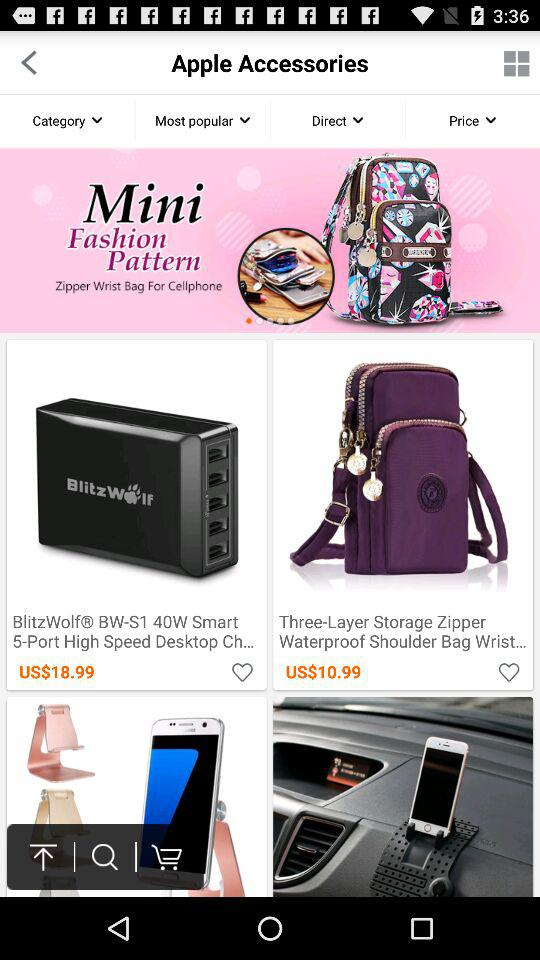What is the price for Blitz Wolf? The price is US$18.99. 